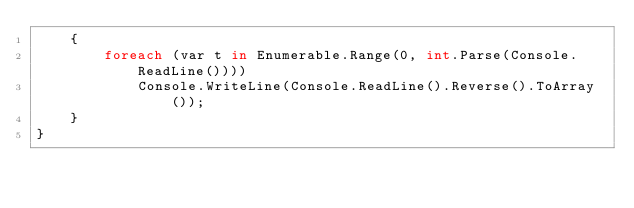<code> <loc_0><loc_0><loc_500><loc_500><_C#_>    {
        foreach (var t in Enumerable.Range(0, int.Parse(Console.ReadLine())))
            Console.WriteLine(Console.ReadLine().Reverse().ToArray());
    }
}
</code> 